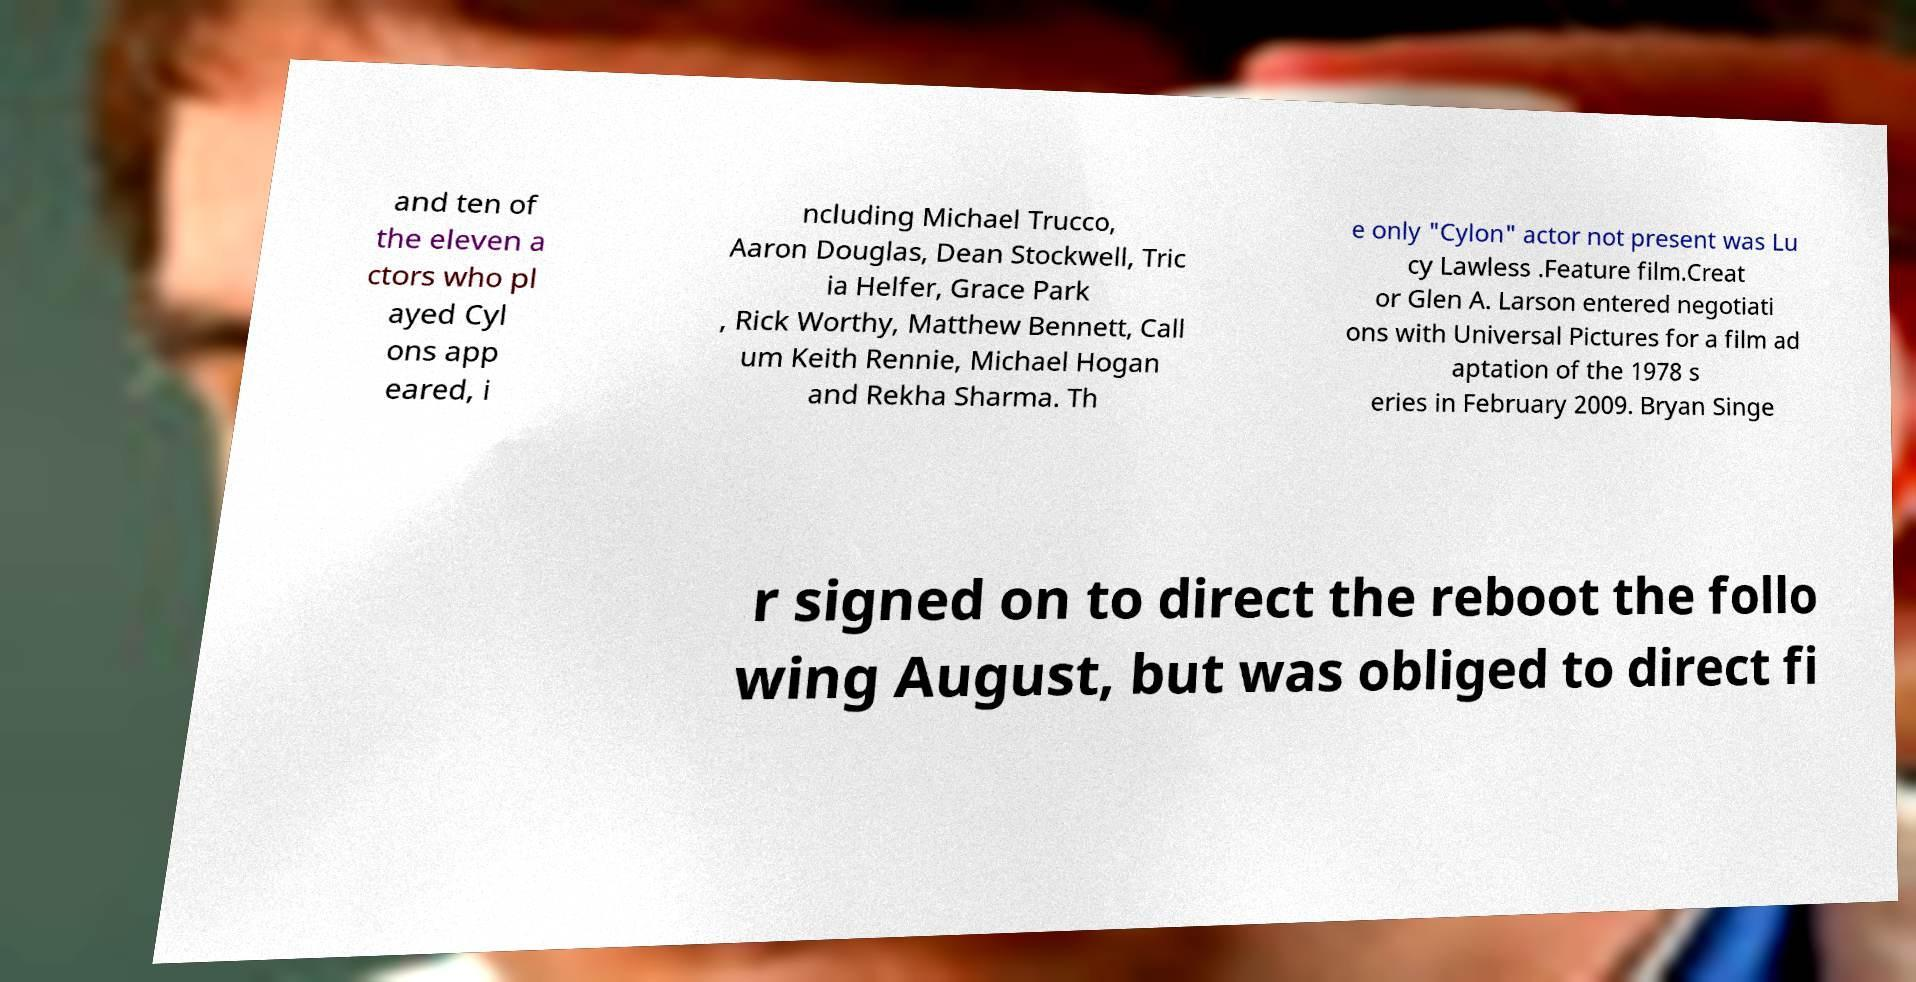I need the written content from this picture converted into text. Can you do that? and ten of the eleven a ctors who pl ayed Cyl ons app eared, i ncluding Michael Trucco, Aaron Douglas, Dean Stockwell, Tric ia Helfer, Grace Park , Rick Worthy, Matthew Bennett, Call um Keith Rennie, Michael Hogan and Rekha Sharma. Th e only "Cylon" actor not present was Lu cy Lawless .Feature film.Creat or Glen A. Larson entered negotiati ons with Universal Pictures for a film ad aptation of the 1978 s eries in February 2009. Bryan Singe r signed on to direct the reboot the follo wing August, but was obliged to direct fi 